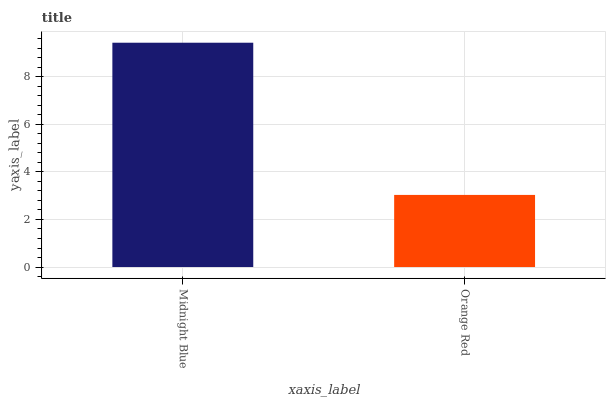Is Orange Red the minimum?
Answer yes or no. Yes. Is Midnight Blue the maximum?
Answer yes or no. Yes. Is Orange Red the maximum?
Answer yes or no. No. Is Midnight Blue greater than Orange Red?
Answer yes or no. Yes. Is Orange Red less than Midnight Blue?
Answer yes or no. Yes. Is Orange Red greater than Midnight Blue?
Answer yes or no. No. Is Midnight Blue less than Orange Red?
Answer yes or no. No. Is Midnight Blue the high median?
Answer yes or no. Yes. Is Orange Red the low median?
Answer yes or no. Yes. Is Orange Red the high median?
Answer yes or no. No. Is Midnight Blue the low median?
Answer yes or no. No. 